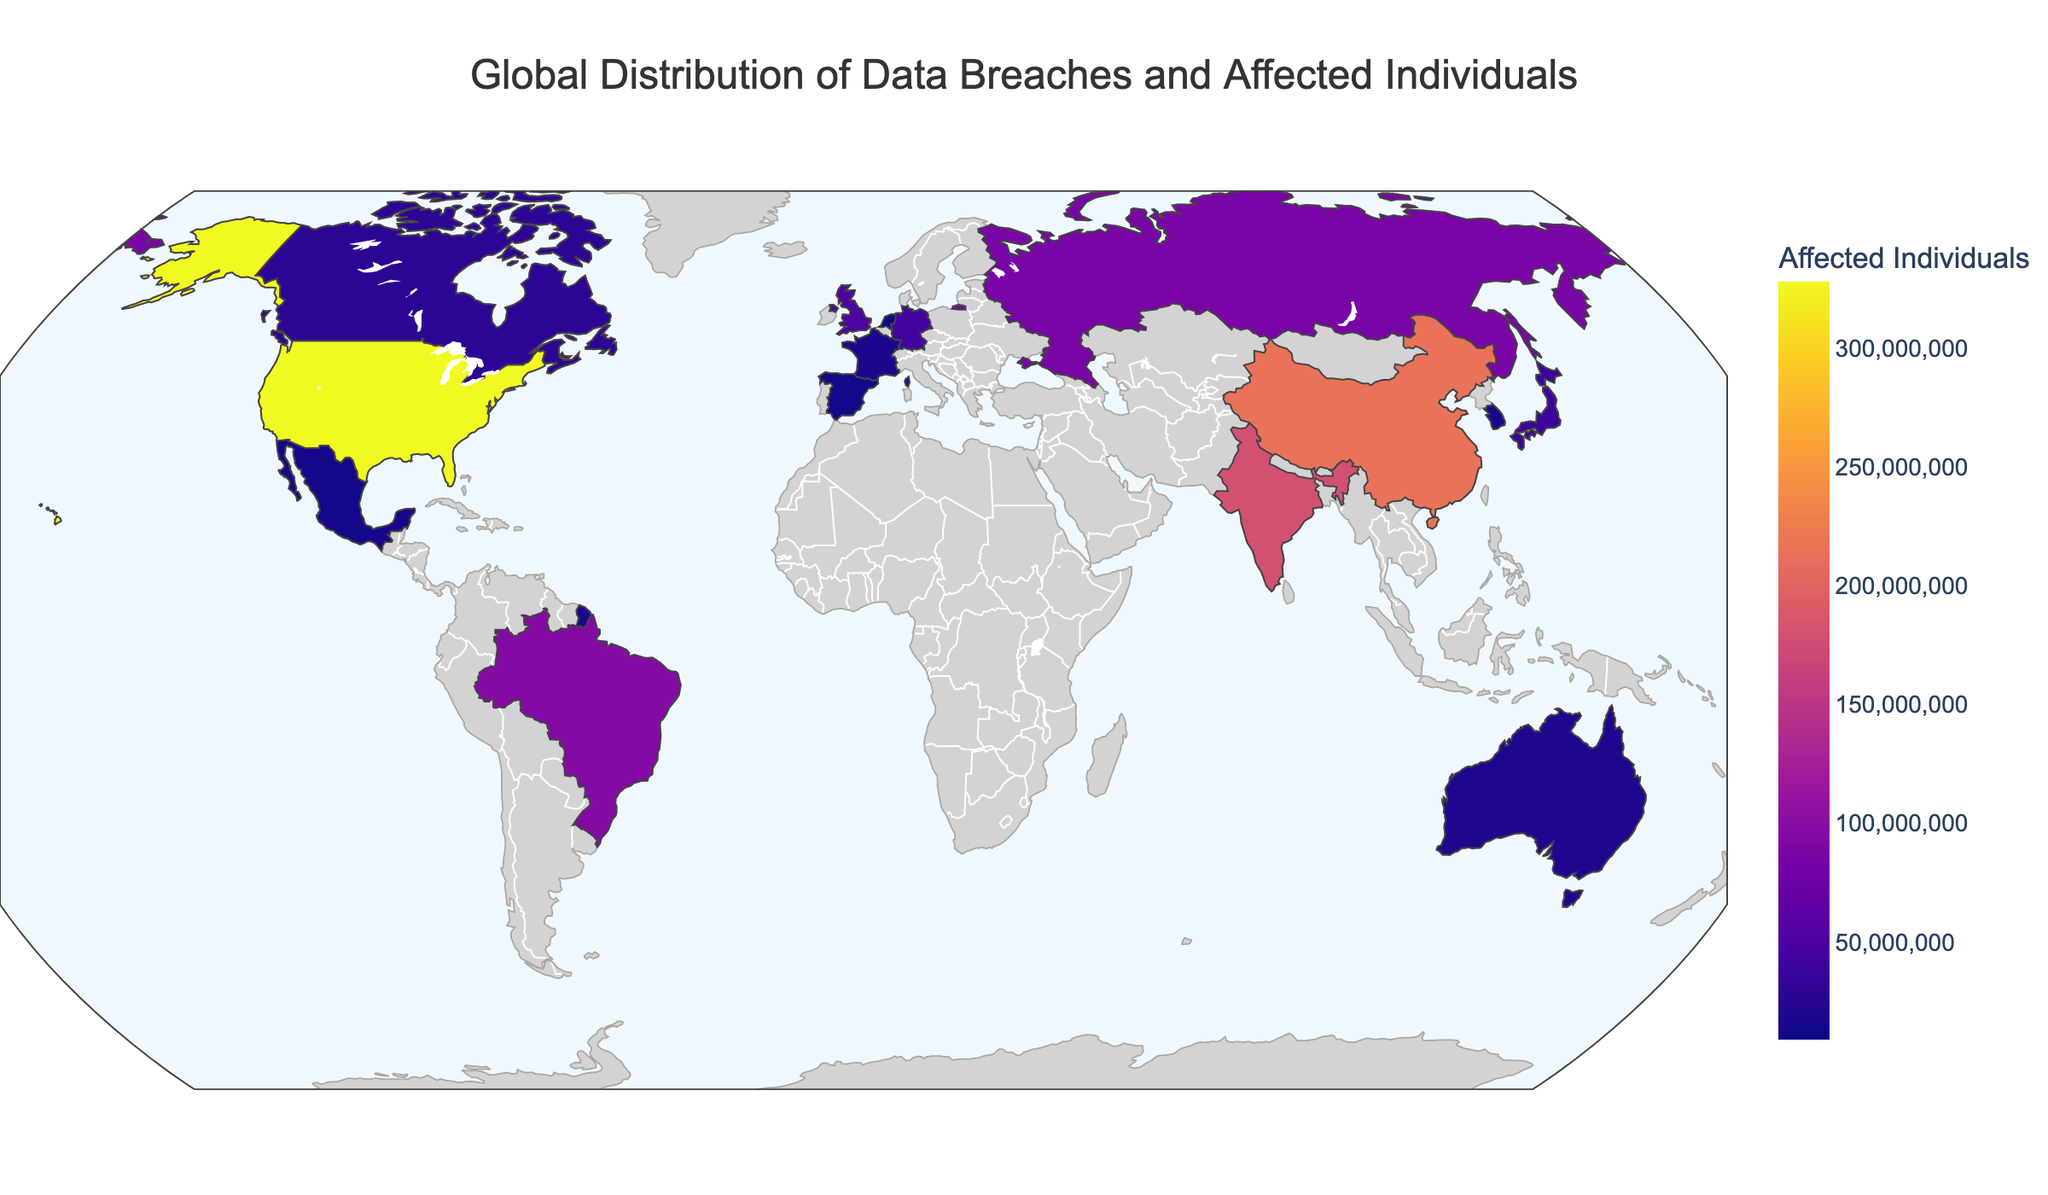What's the title of the map? The title of the map is usually placed at the top of the figure and clearly describes the focus of the visualization. In this case, the title "Global Distribution of Data Breaches and Affected Individuals" is clearly shown at the top.
Answer: Global Distribution of Data Breaches and Affected Individuals Which country has the highest number of affected individuals? By looking at the color intensity on the map and the corresponding hover data, it is evident that the United States stands out with the highest number of affected individuals, totaling 328,000,000.
Answer: United States How many data breaches occurred in Canada? Hovering over Canada on the map will display the relevant data, which includes the number of data breaches. In this case, the figure shows Canada had 231 data breaches.
Answer: 231 Which country has fewer affected individuals, Japan or Germany? By comparing the hover data for Japan and Germany, it can be observed that Japan has 38,000,000 affected individuals, while Germany has 43,000,000 affected individuals, making Japan the country with fewer affected individuals.
Answer: Japan What's the sum of affected individuals in the United Kingdom and Australia? To find this, add the number of affected individuals in both the United Kingdom (52,000,000) and Australia (21,000,000). The calculation is 52,000,000 + 21,000,000 = 73,000,000.
Answer: 73,000,000 Which country has more data breaches, Brazil or Russia? Comparing the hover data, Brazil has 412 data breaches, while Russia has 389 data breaches, indicating Brazil has more data breaches.
Answer: Brazil Which country in the map has the least number of data breaches and how many? By examining the map, the Netherlands stands out as the country with the least number of data breaches, which is 98.
Answer: Netherlands By how many more individuals are affected in China compared to India? By subtracting the number of affected individuals in India (180,000,000) from those in China (215,000,000), we get 215,000,000 - 180,000,000 = 35,000,000. Thus, China has 35,000,000 more affected individuals than India.
Answer: 35,000,000 What is the average number of affected individuals among the countries listed? To find this, sum the number of affected individuals across all countries and divide by the number of countries. The total is 328,000,000 + 215,000,000 + 180,000,000 + 95,000,000 + 87,000,000 + 52,000,000 + 43,000,000 + 38,000,000 + 29,000,000 + 21,000,000 + 18,000,000 + 16,000,000 + 14,000,000 + 12,000,000 + 9,000,000 = 1,157,000,000. Dividing by 15 countries, 1,157,000,000 / 15, we get an average of approximately 77,133,333.
Answer: 77,133,333 